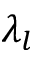<formula> <loc_0><loc_0><loc_500><loc_500>\lambda _ { l }</formula> 